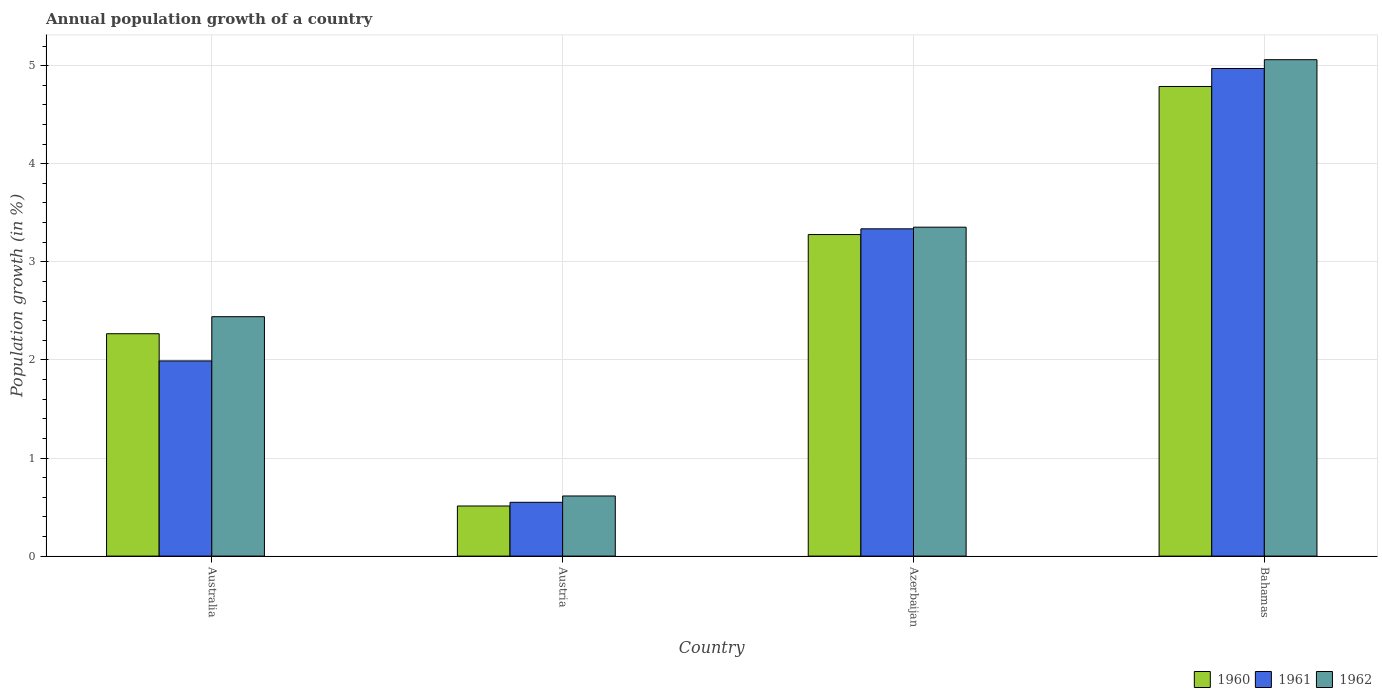Are the number of bars on each tick of the X-axis equal?
Offer a very short reply. Yes. In how many cases, is the number of bars for a given country not equal to the number of legend labels?
Provide a succinct answer. 0. What is the annual population growth in 1962 in Australia?
Your answer should be compact. 2.44. Across all countries, what is the maximum annual population growth in 1961?
Keep it short and to the point. 4.97. Across all countries, what is the minimum annual population growth in 1961?
Make the answer very short. 0.55. In which country was the annual population growth in 1961 maximum?
Give a very brief answer. Bahamas. In which country was the annual population growth in 1961 minimum?
Make the answer very short. Austria. What is the total annual population growth in 1960 in the graph?
Provide a succinct answer. 10.84. What is the difference between the annual population growth in 1961 in Australia and that in Austria?
Offer a very short reply. 1.44. What is the difference between the annual population growth in 1962 in Australia and the annual population growth in 1960 in Austria?
Keep it short and to the point. 1.93. What is the average annual population growth in 1961 per country?
Provide a short and direct response. 2.71. What is the difference between the annual population growth of/in 1960 and annual population growth of/in 1961 in Australia?
Make the answer very short. 0.28. In how many countries, is the annual population growth in 1962 greater than 2 %?
Ensure brevity in your answer.  3. What is the ratio of the annual population growth in 1961 in Australia to that in Azerbaijan?
Offer a very short reply. 0.6. Is the annual population growth in 1961 in Australia less than that in Bahamas?
Your answer should be very brief. Yes. Is the difference between the annual population growth in 1960 in Australia and Bahamas greater than the difference between the annual population growth in 1961 in Australia and Bahamas?
Ensure brevity in your answer.  Yes. What is the difference between the highest and the second highest annual population growth in 1962?
Provide a short and direct response. -0.91. What is the difference between the highest and the lowest annual population growth in 1960?
Keep it short and to the point. 4.28. What does the 1st bar from the left in Austria represents?
Your answer should be very brief. 1960. What does the 3rd bar from the right in Austria represents?
Your answer should be compact. 1960. Is it the case that in every country, the sum of the annual population growth in 1960 and annual population growth in 1961 is greater than the annual population growth in 1962?
Provide a succinct answer. Yes. Are all the bars in the graph horizontal?
Ensure brevity in your answer.  No. Are the values on the major ticks of Y-axis written in scientific E-notation?
Offer a terse response. No. Does the graph contain any zero values?
Your response must be concise. No. Does the graph contain grids?
Offer a terse response. Yes. Where does the legend appear in the graph?
Provide a short and direct response. Bottom right. What is the title of the graph?
Your answer should be compact. Annual population growth of a country. Does "1984" appear as one of the legend labels in the graph?
Ensure brevity in your answer.  No. What is the label or title of the X-axis?
Provide a succinct answer. Country. What is the label or title of the Y-axis?
Your response must be concise. Population growth (in %). What is the Population growth (in %) of 1960 in Australia?
Ensure brevity in your answer.  2.27. What is the Population growth (in %) of 1961 in Australia?
Make the answer very short. 1.99. What is the Population growth (in %) of 1962 in Australia?
Offer a very short reply. 2.44. What is the Population growth (in %) of 1960 in Austria?
Your answer should be very brief. 0.51. What is the Population growth (in %) of 1961 in Austria?
Offer a very short reply. 0.55. What is the Population growth (in %) of 1962 in Austria?
Give a very brief answer. 0.61. What is the Population growth (in %) of 1960 in Azerbaijan?
Keep it short and to the point. 3.28. What is the Population growth (in %) in 1961 in Azerbaijan?
Make the answer very short. 3.34. What is the Population growth (in %) in 1962 in Azerbaijan?
Offer a very short reply. 3.35. What is the Population growth (in %) of 1960 in Bahamas?
Provide a short and direct response. 4.79. What is the Population growth (in %) in 1961 in Bahamas?
Offer a terse response. 4.97. What is the Population growth (in %) in 1962 in Bahamas?
Ensure brevity in your answer.  5.06. Across all countries, what is the maximum Population growth (in %) in 1960?
Offer a very short reply. 4.79. Across all countries, what is the maximum Population growth (in %) in 1961?
Your answer should be very brief. 4.97. Across all countries, what is the maximum Population growth (in %) in 1962?
Ensure brevity in your answer.  5.06. Across all countries, what is the minimum Population growth (in %) of 1960?
Give a very brief answer. 0.51. Across all countries, what is the minimum Population growth (in %) of 1961?
Keep it short and to the point. 0.55. Across all countries, what is the minimum Population growth (in %) of 1962?
Provide a short and direct response. 0.61. What is the total Population growth (in %) of 1960 in the graph?
Provide a succinct answer. 10.84. What is the total Population growth (in %) in 1961 in the graph?
Offer a very short reply. 10.85. What is the total Population growth (in %) of 1962 in the graph?
Provide a short and direct response. 11.47. What is the difference between the Population growth (in %) in 1960 in Australia and that in Austria?
Offer a terse response. 1.76. What is the difference between the Population growth (in %) of 1961 in Australia and that in Austria?
Provide a short and direct response. 1.44. What is the difference between the Population growth (in %) in 1962 in Australia and that in Austria?
Offer a terse response. 1.83. What is the difference between the Population growth (in %) of 1960 in Australia and that in Azerbaijan?
Provide a succinct answer. -1.01. What is the difference between the Population growth (in %) in 1961 in Australia and that in Azerbaijan?
Keep it short and to the point. -1.35. What is the difference between the Population growth (in %) in 1962 in Australia and that in Azerbaijan?
Make the answer very short. -0.91. What is the difference between the Population growth (in %) in 1960 in Australia and that in Bahamas?
Keep it short and to the point. -2.52. What is the difference between the Population growth (in %) in 1961 in Australia and that in Bahamas?
Provide a short and direct response. -2.98. What is the difference between the Population growth (in %) in 1962 in Australia and that in Bahamas?
Ensure brevity in your answer.  -2.62. What is the difference between the Population growth (in %) in 1960 in Austria and that in Azerbaijan?
Your answer should be compact. -2.77. What is the difference between the Population growth (in %) of 1961 in Austria and that in Azerbaijan?
Your answer should be very brief. -2.79. What is the difference between the Population growth (in %) in 1962 in Austria and that in Azerbaijan?
Provide a short and direct response. -2.74. What is the difference between the Population growth (in %) in 1960 in Austria and that in Bahamas?
Make the answer very short. -4.28. What is the difference between the Population growth (in %) in 1961 in Austria and that in Bahamas?
Provide a short and direct response. -4.42. What is the difference between the Population growth (in %) of 1962 in Austria and that in Bahamas?
Your answer should be compact. -4.45. What is the difference between the Population growth (in %) of 1960 in Azerbaijan and that in Bahamas?
Provide a succinct answer. -1.51. What is the difference between the Population growth (in %) in 1961 in Azerbaijan and that in Bahamas?
Ensure brevity in your answer.  -1.63. What is the difference between the Population growth (in %) in 1962 in Azerbaijan and that in Bahamas?
Your answer should be very brief. -1.71. What is the difference between the Population growth (in %) of 1960 in Australia and the Population growth (in %) of 1961 in Austria?
Your answer should be very brief. 1.72. What is the difference between the Population growth (in %) in 1960 in Australia and the Population growth (in %) in 1962 in Austria?
Your answer should be compact. 1.65. What is the difference between the Population growth (in %) of 1961 in Australia and the Population growth (in %) of 1962 in Austria?
Provide a succinct answer. 1.38. What is the difference between the Population growth (in %) in 1960 in Australia and the Population growth (in %) in 1961 in Azerbaijan?
Provide a succinct answer. -1.07. What is the difference between the Population growth (in %) in 1960 in Australia and the Population growth (in %) in 1962 in Azerbaijan?
Provide a succinct answer. -1.09. What is the difference between the Population growth (in %) of 1961 in Australia and the Population growth (in %) of 1962 in Azerbaijan?
Make the answer very short. -1.36. What is the difference between the Population growth (in %) of 1960 in Australia and the Population growth (in %) of 1961 in Bahamas?
Keep it short and to the point. -2.7. What is the difference between the Population growth (in %) of 1960 in Australia and the Population growth (in %) of 1962 in Bahamas?
Provide a short and direct response. -2.79. What is the difference between the Population growth (in %) of 1961 in Australia and the Population growth (in %) of 1962 in Bahamas?
Provide a short and direct response. -3.07. What is the difference between the Population growth (in %) in 1960 in Austria and the Population growth (in %) in 1961 in Azerbaijan?
Offer a very short reply. -2.83. What is the difference between the Population growth (in %) of 1960 in Austria and the Population growth (in %) of 1962 in Azerbaijan?
Provide a succinct answer. -2.84. What is the difference between the Population growth (in %) in 1961 in Austria and the Population growth (in %) in 1962 in Azerbaijan?
Your answer should be compact. -2.8. What is the difference between the Population growth (in %) in 1960 in Austria and the Population growth (in %) in 1961 in Bahamas?
Your answer should be very brief. -4.46. What is the difference between the Population growth (in %) of 1960 in Austria and the Population growth (in %) of 1962 in Bahamas?
Your response must be concise. -4.55. What is the difference between the Population growth (in %) of 1961 in Austria and the Population growth (in %) of 1962 in Bahamas?
Your answer should be compact. -4.51. What is the difference between the Population growth (in %) of 1960 in Azerbaijan and the Population growth (in %) of 1961 in Bahamas?
Provide a succinct answer. -1.69. What is the difference between the Population growth (in %) of 1960 in Azerbaijan and the Population growth (in %) of 1962 in Bahamas?
Your answer should be compact. -1.78. What is the difference between the Population growth (in %) in 1961 in Azerbaijan and the Population growth (in %) in 1962 in Bahamas?
Offer a terse response. -1.72. What is the average Population growth (in %) of 1960 per country?
Provide a short and direct response. 2.71. What is the average Population growth (in %) in 1961 per country?
Provide a short and direct response. 2.71. What is the average Population growth (in %) of 1962 per country?
Offer a terse response. 2.87. What is the difference between the Population growth (in %) in 1960 and Population growth (in %) in 1961 in Australia?
Your answer should be very brief. 0.28. What is the difference between the Population growth (in %) of 1960 and Population growth (in %) of 1962 in Australia?
Give a very brief answer. -0.17. What is the difference between the Population growth (in %) of 1961 and Population growth (in %) of 1962 in Australia?
Your answer should be very brief. -0.45. What is the difference between the Population growth (in %) of 1960 and Population growth (in %) of 1961 in Austria?
Give a very brief answer. -0.04. What is the difference between the Population growth (in %) in 1960 and Population growth (in %) in 1962 in Austria?
Make the answer very short. -0.1. What is the difference between the Population growth (in %) in 1961 and Population growth (in %) in 1962 in Austria?
Provide a short and direct response. -0.06. What is the difference between the Population growth (in %) in 1960 and Population growth (in %) in 1961 in Azerbaijan?
Your answer should be compact. -0.06. What is the difference between the Population growth (in %) of 1960 and Population growth (in %) of 1962 in Azerbaijan?
Offer a terse response. -0.08. What is the difference between the Population growth (in %) in 1961 and Population growth (in %) in 1962 in Azerbaijan?
Your response must be concise. -0.02. What is the difference between the Population growth (in %) in 1960 and Population growth (in %) in 1961 in Bahamas?
Give a very brief answer. -0.18. What is the difference between the Population growth (in %) of 1960 and Population growth (in %) of 1962 in Bahamas?
Offer a very short reply. -0.27. What is the difference between the Population growth (in %) in 1961 and Population growth (in %) in 1962 in Bahamas?
Your response must be concise. -0.09. What is the ratio of the Population growth (in %) of 1960 in Australia to that in Austria?
Your answer should be very brief. 4.44. What is the ratio of the Population growth (in %) in 1961 in Australia to that in Austria?
Your response must be concise. 3.63. What is the ratio of the Population growth (in %) of 1962 in Australia to that in Austria?
Your answer should be very brief. 3.98. What is the ratio of the Population growth (in %) in 1960 in Australia to that in Azerbaijan?
Keep it short and to the point. 0.69. What is the ratio of the Population growth (in %) of 1961 in Australia to that in Azerbaijan?
Your answer should be very brief. 0.6. What is the ratio of the Population growth (in %) in 1962 in Australia to that in Azerbaijan?
Make the answer very short. 0.73. What is the ratio of the Population growth (in %) of 1960 in Australia to that in Bahamas?
Ensure brevity in your answer.  0.47. What is the ratio of the Population growth (in %) of 1961 in Australia to that in Bahamas?
Offer a terse response. 0.4. What is the ratio of the Population growth (in %) of 1962 in Australia to that in Bahamas?
Keep it short and to the point. 0.48. What is the ratio of the Population growth (in %) in 1960 in Austria to that in Azerbaijan?
Ensure brevity in your answer.  0.16. What is the ratio of the Population growth (in %) in 1961 in Austria to that in Azerbaijan?
Ensure brevity in your answer.  0.16. What is the ratio of the Population growth (in %) of 1962 in Austria to that in Azerbaijan?
Provide a short and direct response. 0.18. What is the ratio of the Population growth (in %) of 1960 in Austria to that in Bahamas?
Your response must be concise. 0.11. What is the ratio of the Population growth (in %) of 1961 in Austria to that in Bahamas?
Offer a terse response. 0.11. What is the ratio of the Population growth (in %) of 1962 in Austria to that in Bahamas?
Offer a very short reply. 0.12. What is the ratio of the Population growth (in %) in 1960 in Azerbaijan to that in Bahamas?
Ensure brevity in your answer.  0.68. What is the ratio of the Population growth (in %) in 1961 in Azerbaijan to that in Bahamas?
Your answer should be compact. 0.67. What is the ratio of the Population growth (in %) of 1962 in Azerbaijan to that in Bahamas?
Keep it short and to the point. 0.66. What is the difference between the highest and the second highest Population growth (in %) of 1960?
Keep it short and to the point. 1.51. What is the difference between the highest and the second highest Population growth (in %) of 1961?
Provide a succinct answer. 1.63. What is the difference between the highest and the second highest Population growth (in %) in 1962?
Your response must be concise. 1.71. What is the difference between the highest and the lowest Population growth (in %) in 1960?
Offer a very short reply. 4.28. What is the difference between the highest and the lowest Population growth (in %) in 1961?
Your response must be concise. 4.42. What is the difference between the highest and the lowest Population growth (in %) in 1962?
Keep it short and to the point. 4.45. 